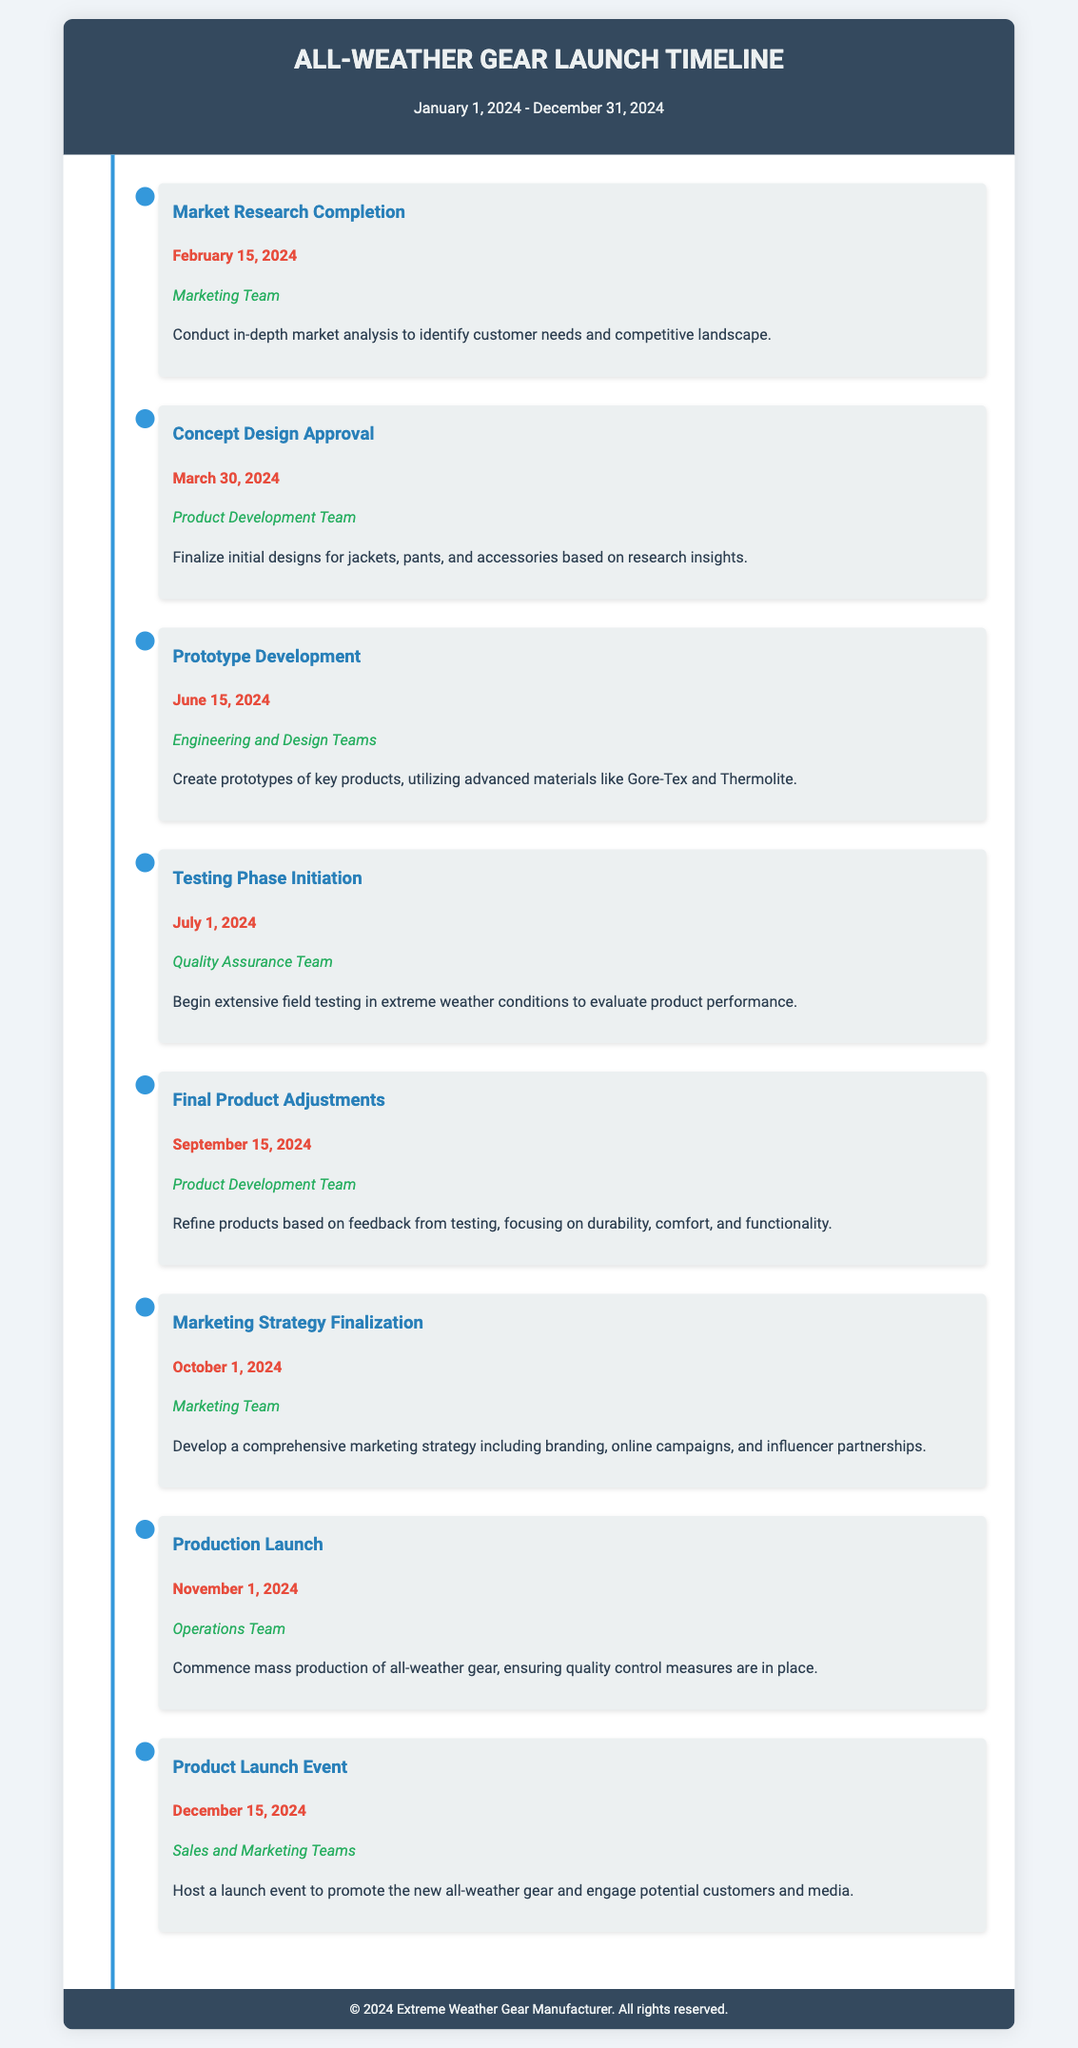What is the title of the document? The title of the document is clearly stated in the header section.
Answer: All-Weather Gear Launch Timeline When does the market research completion take place? The specific date for the market research completion is provided under that milestone.
Answer: February 15, 2024 Who is responsible for the prototype development? The responsibility is assigned in the prototype development milestone section.
Answer: Engineering and Design Teams What is the date for the final product adjustments? The date for final product adjustments is noted in the corresponding milestone.
Answer: September 15, 2024 What major material will be utilized in prototype development? The document mentions specific materials in the description of the prototype development milestone.
Answer: Gore-Tex and Thermolite Which team develops the marketing strategy? The responsible team for the marketing strategy is specified in the relevant milestone.
Answer: Marketing Team How many major milestones are listed in the document? The total number of milestones can be counted from the sections in the timeline.
Answer: Eight What event is scheduled for December 15, 2024? The document outlines a specific event occurring on that date.
Answer: Product Launch Event 